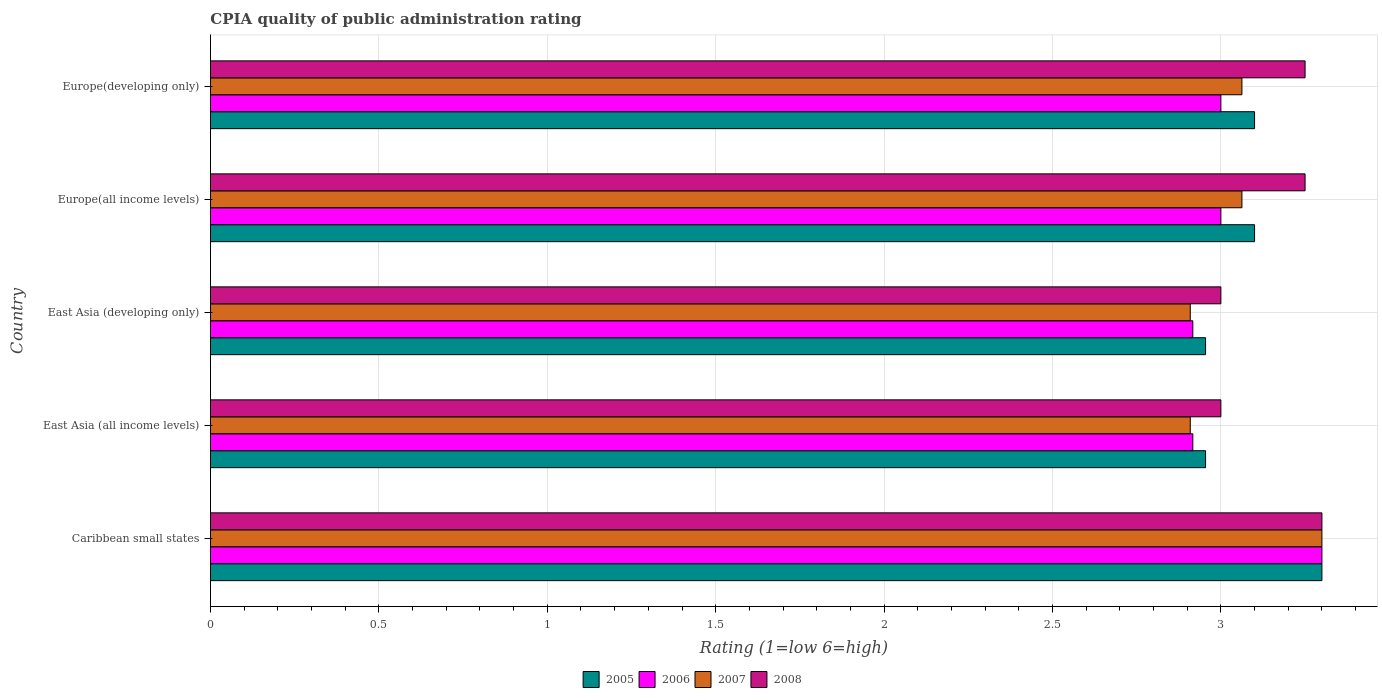How many different coloured bars are there?
Offer a terse response. 4. How many groups of bars are there?
Offer a very short reply. 5. Are the number of bars per tick equal to the number of legend labels?
Give a very brief answer. Yes. Are the number of bars on each tick of the Y-axis equal?
Offer a very short reply. Yes. How many bars are there on the 4th tick from the bottom?
Keep it short and to the point. 4. What is the label of the 3rd group of bars from the top?
Your answer should be very brief. East Asia (developing only). In how many cases, is the number of bars for a given country not equal to the number of legend labels?
Your answer should be compact. 0. What is the CPIA rating in 2006 in East Asia (developing only)?
Give a very brief answer. 2.92. Across all countries, what is the maximum CPIA rating in 2007?
Your answer should be very brief. 3.3. Across all countries, what is the minimum CPIA rating in 2005?
Offer a very short reply. 2.95. In which country was the CPIA rating in 2007 maximum?
Offer a very short reply. Caribbean small states. In which country was the CPIA rating in 2005 minimum?
Offer a very short reply. East Asia (all income levels). What is the total CPIA rating in 2007 in the graph?
Your response must be concise. 15.24. What is the difference between the CPIA rating in 2007 in East Asia (developing only) and that in Europe(all income levels)?
Your answer should be very brief. -0.15. What is the difference between the CPIA rating in 2006 in Caribbean small states and the CPIA rating in 2008 in Europe(all income levels)?
Keep it short and to the point. 0.05. What is the average CPIA rating in 2007 per country?
Offer a terse response. 3.05. What is the difference between the CPIA rating in 2008 and CPIA rating in 2005 in Europe(all income levels)?
Make the answer very short. 0.15. In how many countries, is the CPIA rating in 2008 greater than 0.5 ?
Provide a succinct answer. 5. What is the ratio of the CPIA rating in 2006 in Caribbean small states to that in Europe(all income levels)?
Give a very brief answer. 1.1. Is the CPIA rating in 2005 in Europe(all income levels) less than that in Europe(developing only)?
Give a very brief answer. No. Is the difference between the CPIA rating in 2008 in Caribbean small states and Europe(all income levels) greater than the difference between the CPIA rating in 2005 in Caribbean small states and Europe(all income levels)?
Your answer should be very brief. No. What is the difference between the highest and the second highest CPIA rating in 2006?
Offer a very short reply. 0.3. What is the difference between the highest and the lowest CPIA rating in 2005?
Make the answer very short. 0.35. In how many countries, is the CPIA rating in 2005 greater than the average CPIA rating in 2005 taken over all countries?
Ensure brevity in your answer.  3. Is the sum of the CPIA rating in 2007 in East Asia (all income levels) and Europe(all income levels) greater than the maximum CPIA rating in 2008 across all countries?
Make the answer very short. Yes. What does the 4th bar from the bottom in Europe(developing only) represents?
Your answer should be very brief. 2008. How many countries are there in the graph?
Offer a very short reply. 5. What is the difference between two consecutive major ticks on the X-axis?
Your answer should be very brief. 0.5. Does the graph contain any zero values?
Your answer should be compact. No. Where does the legend appear in the graph?
Give a very brief answer. Bottom center. How many legend labels are there?
Your answer should be very brief. 4. What is the title of the graph?
Provide a succinct answer. CPIA quality of public administration rating. What is the label or title of the X-axis?
Make the answer very short. Rating (1=low 6=high). What is the label or title of the Y-axis?
Provide a succinct answer. Country. What is the Rating (1=low 6=high) in 2005 in Caribbean small states?
Provide a short and direct response. 3.3. What is the Rating (1=low 6=high) in 2005 in East Asia (all income levels)?
Provide a short and direct response. 2.95. What is the Rating (1=low 6=high) in 2006 in East Asia (all income levels)?
Provide a succinct answer. 2.92. What is the Rating (1=low 6=high) in 2007 in East Asia (all income levels)?
Offer a very short reply. 2.91. What is the Rating (1=low 6=high) in 2005 in East Asia (developing only)?
Your answer should be compact. 2.95. What is the Rating (1=low 6=high) in 2006 in East Asia (developing only)?
Provide a short and direct response. 2.92. What is the Rating (1=low 6=high) in 2007 in East Asia (developing only)?
Offer a very short reply. 2.91. What is the Rating (1=low 6=high) in 2007 in Europe(all income levels)?
Make the answer very short. 3.06. What is the Rating (1=low 6=high) of 2007 in Europe(developing only)?
Provide a succinct answer. 3.06. Across all countries, what is the maximum Rating (1=low 6=high) in 2005?
Your answer should be compact. 3.3. Across all countries, what is the maximum Rating (1=low 6=high) of 2006?
Offer a terse response. 3.3. Across all countries, what is the minimum Rating (1=low 6=high) of 2005?
Your answer should be very brief. 2.95. Across all countries, what is the minimum Rating (1=low 6=high) of 2006?
Keep it short and to the point. 2.92. Across all countries, what is the minimum Rating (1=low 6=high) in 2007?
Your answer should be compact. 2.91. Across all countries, what is the minimum Rating (1=low 6=high) in 2008?
Ensure brevity in your answer.  3. What is the total Rating (1=low 6=high) of 2005 in the graph?
Offer a terse response. 15.41. What is the total Rating (1=low 6=high) of 2006 in the graph?
Your response must be concise. 15.13. What is the total Rating (1=low 6=high) in 2007 in the graph?
Offer a terse response. 15.24. What is the total Rating (1=low 6=high) in 2008 in the graph?
Your answer should be compact. 15.8. What is the difference between the Rating (1=low 6=high) in 2005 in Caribbean small states and that in East Asia (all income levels)?
Give a very brief answer. 0.35. What is the difference between the Rating (1=low 6=high) in 2006 in Caribbean small states and that in East Asia (all income levels)?
Give a very brief answer. 0.38. What is the difference between the Rating (1=low 6=high) of 2007 in Caribbean small states and that in East Asia (all income levels)?
Make the answer very short. 0.39. What is the difference between the Rating (1=low 6=high) of 2008 in Caribbean small states and that in East Asia (all income levels)?
Make the answer very short. 0.3. What is the difference between the Rating (1=low 6=high) in 2005 in Caribbean small states and that in East Asia (developing only)?
Give a very brief answer. 0.35. What is the difference between the Rating (1=low 6=high) of 2006 in Caribbean small states and that in East Asia (developing only)?
Your answer should be very brief. 0.38. What is the difference between the Rating (1=low 6=high) in 2007 in Caribbean small states and that in East Asia (developing only)?
Offer a very short reply. 0.39. What is the difference between the Rating (1=low 6=high) in 2006 in Caribbean small states and that in Europe(all income levels)?
Your answer should be very brief. 0.3. What is the difference between the Rating (1=low 6=high) of 2007 in Caribbean small states and that in Europe(all income levels)?
Make the answer very short. 0.24. What is the difference between the Rating (1=low 6=high) of 2008 in Caribbean small states and that in Europe(all income levels)?
Your response must be concise. 0.05. What is the difference between the Rating (1=low 6=high) in 2007 in Caribbean small states and that in Europe(developing only)?
Provide a short and direct response. 0.24. What is the difference between the Rating (1=low 6=high) of 2005 in East Asia (all income levels) and that in East Asia (developing only)?
Make the answer very short. 0. What is the difference between the Rating (1=low 6=high) of 2007 in East Asia (all income levels) and that in East Asia (developing only)?
Offer a terse response. 0. What is the difference between the Rating (1=low 6=high) in 2005 in East Asia (all income levels) and that in Europe(all income levels)?
Give a very brief answer. -0.15. What is the difference between the Rating (1=low 6=high) of 2006 in East Asia (all income levels) and that in Europe(all income levels)?
Provide a succinct answer. -0.08. What is the difference between the Rating (1=low 6=high) in 2007 in East Asia (all income levels) and that in Europe(all income levels)?
Ensure brevity in your answer.  -0.15. What is the difference between the Rating (1=low 6=high) of 2008 in East Asia (all income levels) and that in Europe(all income levels)?
Provide a short and direct response. -0.25. What is the difference between the Rating (1=low 6=high) in 2005 in East Asia (all income levels) and that in Europe(developing only)?
Your response must be concise. -0.15. What is the difference between the Rating (1=low 6=high) in 2006 in East Asia (all income levels) and that in Europe(developing only)?
Make the answer very short. -0.08. What is the difference between the Rating (1=low 6=high) in 2007 in East Asia (all income levels) and that in Europe(developing only)?
Keep it short and to the point. -0.15. What is the difference between the Rating (1=low 6=high) of 2005 in East Asia (developing only) and that in Europe(all income levels)?
Offer a terse response. -0.15. What is the difference between the Rating (1=low 6=high) in 2006 in East Asia (developing only) and that in Europe(all income levels)?
Give a very brief answer. -0.08. What is the difference between the Rating (1=low 6=high) of 2007 in East Asia (developing only) and that in Europe(all income levels)?
Offer a very short reply. -0.15. What is the difference between the Rating (1=low 6=high) of 2008 in East Asia (developing only) and that in Europe(all income levels)?
Provide a short and direct response. -0.25. What is the difference between the Rating (1=low 6=high) in 2005 in East Asia (developing only) and that in Europe(developing only)?
Make the answer very short. -0.15. What is the difference between the Rating (1=low 6=high) in 2006 in East Asia (developing only) and that in Europe(developing only)?
Your answer should be very brief. -0.08. What is the difference between the Rating (1=low 6=high) of 2007 in East Asia (developing only) and that in Europe(developing only)?
Provide a succinct answer. -0.15. What is the difference between the Rating (1=low 6=high) of 2007 in Europe(all income levels) and that in Europe(developing only)?
Your response must be concise. 0. What is the difference between the Rating (1=low 6=high) in 2005 in Caribbean small states and the Rating (1=low 6=high) in 2006 in East Asia (all income levels)?
Offer a very short reply. 0.38. What is the difference between the Rating (1=low 6=high) of 2005 in Caribbean small states and the Rating (1=low 6=high) of 2007 in East Asia (all income levels)?
Ensure brevity in your answer.  0.39. What is the difference between the Rating (1=low 6=high) in 2006 in Caribbean small states and the Rating (1=low 6=high) in 2007 in East Asia (all income levels)?
Provide a short and direct response. 0.39. What is the difference between the Rating (1=low 6=high) of 2006 in Caribbean small states and the Rating (1=low 6=high) of 2008 in East Asia (all income levels)?
Provide a short and direct response. 0.3. What is the difference between the Rating (1=low 6=high) of 2007 in Caribbean small states and the Rating (1=low 6=high) of 2008 in East Asia (all income levels)?
Make the answer very short. 0.3. What is the difference between the Rating (1=low 6=high) of 2005 in Caribbean small states and the Rating (1=low 6=high) of 2006 in East Asia (developing only)?
Offer a terse response. 0.38. What is the difference between the Rating (1=low 6=high) in 2005 in Caribbean small states and the Rating (1=low 6=high) in 2007 in East Asia (developing only)?
Ensure brevity in your answer.  0.39. What is the difference between the Rating (1=low 6=high) in 2006 in Caribbean small states and the Rating (1=low 6=high) in 2007 in East Asia (developing only)?
Provide a succinct answer. 0.39. What is the difference between the Rating (1=low 6=high) of 2007 in Caribbean small states and the Rating (1=low 6=high) of 2008 in East Asia (developing only)?
Make the answer very short. 0.3. What is the difference between the Rating (1=low 6=high) in 2005 in Caribbean small states and the Rating (1=low 6=high) in 2006 in Europe(all income levels)?
Offer a very short reply. 0.3. What is the difference between the Rating (1=low 6=high) in 2005 in Caribbean small states and the Rating (1=low 6=high) in 2007 in Europe(all income levels)?
Keep it short and to the point. 0.24. What is the difference between the Rating (1=low 6=high) of 2006 in Caribbean small states and the Rating (1=low 6=high) of 2007 in Europe(all income levels)?
Your response must be concise. 0.24. What is the difference between the Rating (1=low 6=high) in 2006 in Caribbean small states and the Rating (1=low 6=high) in 2008 in Europe(all income levels)?
Your answer should be compact. 0.05. What is the difference between the Rating (1=low 6=high) in 2005 in Caribbean small states and the Rating (1=low 6=high) in 2006 in Europe(developing only)?
Provide a short and direct response. 0.3. What is the difference between the Rating (1=low 6=high) in 2005 in Caribbean small states and the Rating (1=low 6=high) in 2007 in Europe(developing only)?
Ensure brevity in your answer.  0.24. What is the difference between the Rating (1=low 6=high) of 2006 in Caribbean small states and the Rating (1=low 6=high) of 2007 in Europe(developing only)?
Offer a very short reply. 0.24. What is the difference between the Rating (1=low 6=high) in 2006 in Caribbean small states and the Rating (1=low 6=high) in 2008 in Europe(developing only)?
Make the answer very short. 0.05. What is the difference between the Rating (1=low 6=high) in 2005 in East Asia (all income levels) and the Rating (1=low 6=high) in 2006 in East Asia (developing only)?
Offer a very short reply. 0.04. What is the difference between the Rating (1=low 6=high) in 2005 in East Asia (all income levels) and the Rating (1=low 6=high) in 2007 in East Asia (developing only)?
Your answer should be very brief. 0.05. What is the difference between the Rating (1=low 6=high) in 2005 in East Asia (all income levels) and the Rating (1=low 6=high) in 2008 in East Asia (developing only)?
Provide a succinct answer. -0.05. What is the difference between the Rating (1=low 6=high) in 2006 in East Asia (all income levels) and the Rating (1=low 6=high) in 2007 in East Asia (developing only)?
Make the answer very short. 0.01. What is the difference between the Rating (1=low 6=high) in 2006 in East Asia (all income levels) and the Rating (1=low 6=high) in 2008 in East Asia (developing only)?
Give a very brief answer. -0.08. What is the difference between the Rating (1=low 6=high) in 2007 in East Asia (all income levels) and the Rating (1=low 6=high) in 2008 in East Asia (developing only)?
Your answer should be compact. -0.09. What is the difference between the Rating (1=low 6=high) in 2005 in East Asia (all income levels) and the Rating (1=low 6=high) in 2006 in Europe(all income levels)?
Provide a succinct answer. -0.05. What is the difference between the Rating (1=low 6=high) of 2005 in East Asia (all income levels) and the Rating (1=low 6=high) of 2007 in Europe(all income levels)?
Keep it short and to the point. -0.11. What is the difference between the Rating (1=low 6=high) of 2005 in East Asia (all income levels) and the Rating (1=low 6=high) of 2008 in Europe(all income levels)?
Give a very brief answer. -0.3. What is the difference between the Rating (1=low 6=high) of 2006 in East Asia (all income levels) and the Rating (1=low 6=high) of 2007 in Europe(all income levels)?
Offer a very short reply. -0.15. What is the difference between the Rating (1=low 6=high) of 2007 in East Asia (all income levels) and the Rating (1=low 6=high) of 2008 in Europe(all income levels)?
Your response must be concise. -0.34. What is the difference between the Rating (1=low 6=high) in 2005 in East Asia (all income levels) and the Rating (1=low 6=high) in 2006 in Europe(developing only)?
Ensure brevity in your answer.  -0.05. What is the difference between the Rating (1=low 6=high) in 2005 in East Asia (all income levels) and the Rating (1=low 6=high) in 2007 in Europe(developing only)?
Your answer should be very brief. -0.11. What is the difference between the Rating (1=low 6=high) of 2005 in East Asia (all income levels) and the Rating (1=low 6=high) of 2008 in Europe(developing only)?
Give a very brief answer. -0.3. What is the difference between the Rating (1=low 6=high) of 2006 in East Asia (all income levels) and the Rating (1=low 6=high) of 2007 in Europe(developing only)?
Give a very brief answer. -0.15. What is the difference between the Rating (1=low 6=high) of 2006 in East Asia (all income levels) and the Rating (1=low 6=high) of 2008 in Europe(developing only)?
Give a very brief answer. -0.33. What is the difference between the Rating (1=low 6=high) of 2007 in East Asia (all income levels) and the Rating (1=low 6=high) of 2008 in Europe(developing only)?
Your response must be concise. -0.34. What is the difference between the Rating (1=low 6=high) in 2005 in East Asia (developing only) and the Rating (1=low 6=high) in 2006 in Europe(all income levels)?
Your answer should be very brief. -0.05. What is the difference between the Rating (1=low 6=high) in 2005 in East Asia (developing only) and the Rating (1=low 6=high) in 2007 in Europe(all income levels)?
Provide a succinct answer. -0.11. What is the difference between the Rating (1=low 6=high) of 2005 in East Asia (developing only) and the Rating (1=low 6=high) of 2008 in Europe(all income levels)?
Your response must be concise. -0.3. What is the difference between the Rating (1=low 6=high) of 2006 in East Asia (developing only) and the Rating (1=low 6=high) of 2007 in Europe(all income levels)?
Offer a very short reply. -0.15. What is the difference between the Rating (1=low 6=high) of 2006 in East Asia (developing only) and the Rating (1=low 6=high) of 2008 in Europe(all income levels)?
Your response must be concise. -0.33. What is the difference between the Rating (1=low 6=high) in 2007 in East Asia (developing only) and the Rating (1=low 6=high) in 2008 in Europe(all income levels)?
Provide a short and direct response. -0.34. What is the difference between the Rating (1=low 6=high) of 2005 in East Asia (developing only) and the Rating (1=low 6=high) of 2006 in Europe(developing only)?
Keep it short and to the point. -0.05. What is the difference between the Rating (1=low 6=high) of 2005 in East Asia (developing only) and the Rating (1=low 6=high) of 2007 in Europe(developing only)?
Your answer should be compact. -0.11. What is the difference between the Rating (1=low 6=high) of 2005 in East Asia (developing only) and the Rating (1=low 6=high) of 2008 in Europe(developing only)?
Give a very brief answer. -0.3. What is the difference between the Rating (1=low 6=high) in 2006 in East Asia (developing only) and the Rating (1=low 6=high) in 2007 in Europe(developing only)?
Give a very brief answer. -0.15. What is the difference between the Rating (1=low 6=high) of 2007 in East Asia (developing only) and the Rating (1=low 6=high) of 2008 in Europe(developing only)?
Provide a short and direct response. -0.34. What is the difference between the Rating (1=low 6=high) in 2005 in Europe(all income levels) and the Rating (1=low 6=high) in 2007 in Europe(developing only)?
Provide a succinct answer. 0.04. What is the difference between the Rating (1=low 6=high) in 2005 in Europe(all income levels) and the Rating (1=low 6=high) in 2008 in Europe(developing only)?
Give a very brief answer. -0.15. What is the difference between the Rating (1=low 6=high) of 2006 in Europe(all income levels) and the Rating (1=low 6=high) of 2007 in Europe(developing only)?
Your response must be concise. -0.06. What is the difference between the Rating (1=low 6=high) in 2006 in Europe(all income levels) and the Rating (1=low 6=high) in 2008 in Europe(developing only)?
Your answer should be compact. -0.25. What is the difference between the Rating (1=low 6=high) in 2007 in Europe(all income levels) and the Rating (1=low 6=high) in 2008 in Europe(developing only)?
Make the answer very short. -0.19. What is the average Rating (1=low 6=high) of 2005 per country?
Make the answer very short. 3.08. What is the average Rating (1=low 6=high) of 2006 per country?
Offer a very short reply. 3.03. What is the average Rating (1=low 6=high) of 2007 per country?
Your response must be concise. 3.05. What is the average Rating (1=low 6=high) in 2008 per country?
Provide a succinct answer. 3.16. What is the difference between the Rating (1=low 6=high) of 2005 and Rating (1=low 6=high) of 2006 in Caribbean small states?
Your response must be concise. 0. What is the difference between the Rating (1=low 6=high) of 2005 and Rating (1=low 6=high) of 2006 in East Asia (all income levels)?
Ensure brevity in your answer.  0.04. What is the difference between the Rating (1=low 6=high) of 2005 and Rating (1=low 6=high) of 2007 in East Asia (all income levels)?
Your answer should be compact. 0.05. What is the difference between the Rating (1=low 6=high) in 2005 and Rating (1=low 6=high) in 2008 in East Asia (all income levels)?
Offer a terse response. -0.05. What is the difference between the Rating (1=low 6=high) in 2006 and Rating (1=low 6=high) in 2007 in East Asia (all income levels)?
Offer a very short reply. 0.01. What is the difference between the Rating (1=low 6=high) of 2006 and Rating (1=low 6=high) of 2008 in East Asia (all income levels)?
Ensure brevity in your answer.  -0.08. What is the difference between the Rating (1=low 6=high) in 2007 and Rating (1=low 6=high) in 2008 in East Asia (all income levels)?
Your response must be concise. -0.09. What is the difference between the Rating (1=low 6=high) of 2005 and Rating (1=low 6=high) of 2006 in East Asia (developing only)?
Your answer should be very brief. 0.04. What is the difference between the Rating (1=low 6=high) in 2005 and Rating (1=low 6=high) in 2007 in East Asia (developing only)?
Keep it short and to the point. 0.05. What is the difference between the Rating (1=low 6=high) of 2005 and Rating (1=low 6=high) of 2008 in East Asia (developing only)?
Give a very brief answer. -0.05. What is the difference between the Rating (1=low 6=high) of 2006 and Rating (1=low 6=high) of 2007 in East Asia (developing only)?
Provide a succinct answer. 0.01. What is the difference between the Rating (1=low 6=high) in 2006 and Rating (1=low 6=high) in 2008 in East Asia (developing only)?
Your answer should be compact. -0.08. What is the difference between the Rating (1=low 6=high) in 2007 and Rating (1=low 6=high) in 2008 in East Asia (developing only)?
Provide a short and direct response. -0.09. What is the difference between the Rating (1=low 6=high) in 2005 and Rating (1=low 6=high) in 2007 in Europe(all income levels)?
Your answer should be compact. 0.04. What is the difference between the Rating (1=low 6=high) in 2005 and Rating (1=low 6=high) in 2008 in Europe(all income levels)?
Make the answer very short. -0.15. What is the difference between the Rating (1=low 6=high) in 2006 and Rating (1=low 6=high) in 2007 in Europe(all income levels)?
Your answer should be compact. -0.06. What is the difference between the Rating (1=low 6=high) in 2007 and Rating (1=low 6=high) in 2008 in Europe(all income levels)?
Keep it short and to the point. -0.19. What is the difference between the Rating (1=low 6=high) of 2005 and Rating (1=low 6=high) of 2006 in Europe(developing only)?
Provide a succinct answer. 0.1. What is the difference between the Rating (1=low 6=high) in 2005 and Rating (1=low 6=high) in 2007 in Europe(developing only)?
Provide a short and direct response. 0.04. What is the difference between the Rating (1=low 6=high) in 2006 and Rating (1=low 6=high) in 2007 in Europe(developing only)?
Make the answer very short. -0.06. What is the difference between the Rating (1=low 6=high) of 2007 and Rating (1=low 6=high) of 2008 in Europe(developing only)?
Give a very brief answer. -0.19. What is the ratio of the Rating (1=low 6=high) of 2005 in Caribbean small states to that in East Asia (all income levels)?
Your response must be concise. 1.12. What is the ratio of the Rating (1=low 6=high) in 2006 in Caribbean small states to that in East Asia (all income levels)?
Your answer should be very brief. 1.13. What is the ratio of the Rating (1=low 6=high) of 2007 in Caribbean small states to that in East Asia (all income levels)?
Your answer should be compact. 1.13. What is the ratio of the Rating (1=low 6=high) in 2005 in Caribbean small states to that in East Asia (developing only)?
Make the answer very short. 1.12. What is the ratio of the Rating (1=low 6=high) in 2006 in Caribbean small states to that in East Asia (developing only)?
Offer a very short reply. 1.13. What is the ratio of the Rating (1=low 6=high) of 2007 in Caribbean small states to that in East Asia (developing only)?
Make the answer very short. 1.13. What is the ratio of the Rating (1=low 6=high) in 2005 in Caribbean small states to that in Europe(all income levels)?
Provide a short and direct response. 1.06. What is the ratio of the Rating (1=low 6=high) of 2006 in Caribbean small states to that in Europe(all income levels)?
Make the answer very short. 1.1. What is the ratio of the Rating (1=low 6=high) in 2007 in Caribbean small states to that in Europe(all income levels)?
Provide a short and direct response. 1.08. What is the ratio of the Rating (1=low 6=high) in 2008 in Caribbean small states to that in Europe(all income levels)?
Ensure brevity in your answer.  1.02. What is the ratio of the Rating (1=low 6=high) of 2005 in Caribbean small states to that in Europe(developing only)?
Keep it short and to the point. 1.06. What is the ratio of the Rating (1=low 6=high) in 2007 in Caribbean small states to that in Europe(developing only)?
Keep it short and to the point. 1.08. What is the ratio of the Rating (1=low 6=high) in 2008 in Caribbean small states to that in Europe(developing only)?
Provide a short and direct response. 1.02. What is the ratio of the Rating (1=low 6=high) in 2006 in East Asia (all income levels) to that in East Asia (developing only)?
Provide a short and direct response. 1. What is the ratio of the Rating (1=low 6=high) in 2007 in East Asia (all income levels) to that in East Asia (developing only)?
Provide a succinct answer. 1. What is the ratio of the Rating (1=low 6=high) in 2005 in East Asia (all income levels) to that in Europe(all income levels)?
Provide a short and direct response. 0.95. What is the ratio of the Rating (1=low 6=high) of 2006 in East Asia (all income levels) to that in Europe(all income levels)?
Your response must be concise. 0.97. What is the ratio of the Rating (1=low 6=high) of 2007 in East Asia (all income levels) to that in Europe(all income levels)?
Offer a very short reply. 0.95. What is the ratio of the Rating (1=low 6=high) of 2005 in East Asia (all income levels) to that in Europe(developing only)?
Keep it short and to the point. 0.95. What is the ratio of the Rating (1=low 6=high) in 2006 in East Asia (all income levels) to that in Europe(developing only)?
Provide a short and direct response. 0.97. What is the ratio of the Rating (1=low 6=high) in 2007 in East Asia (all income levels) to that in Europe(developing only)?
Provide a succinct answer. 0.95. What is the ratio of the Rating (1=low 6=high) in 2008 in East Asia (all income levels) to that in Europe(developing only)?
Your response must be concise. 0.92. What is the ratio of the Rating (1=low 6=high) in 2005 in East Asia (developing only) to that in Europe(all income levels)?
Keep it short and to the point. 0.95. What is the ratio of the Rating (1=low 6=high) in 2006 in East Asia (developing only) to that in Europe(all income levels)?
Offer a very short reply. 0.97. What is the ratio of the Rating (1=low 6=high) in 2007 in East Asia (developing only) to that in Europe(all income levels)?
Offer a terse response. 0.95. What is the ratio of the Rating (1=low 6=high) of 2005 in East Asia (developing only) to that in Europe(developing only)?
Provide a succinct answer. 0.95. What is the ratio of the Rating (1=low 6=high) in 2006 in East Asia (developing only) to that in Europe(developing only)?
Make the answer very short. 0.97. What is the ratio of the Rating (1=low 6=high) in 2007 in East Asia (developing only) to that in Europe(developing only)?
Give a very brief answer. 0.95. What is the ratio of the Rating (1=low 6=high) of 2006 in Europe(all income levels) to that in Europe(developing only)?
Your response must be concise. 1. What is the ratio of the Rating (1=low 6=high) in 2008 in Europe(all income levels) to that in Europe(developing only)?
Your response must be concise. 1. What is the difference between the highest and the second highest Rating (1=low 6=high) in 2005?
Provide a succinct answer. 0.2. What is the difference between the highest and the second highest Rating (1=low 6=high) of 2006?
Provide a succinct answer. 0.3. What is the difference between the highest and the second highest Rating (1=low 6=high) of 2007?
Make the answer very short. 0.24. What is the difference between the highest and the second highest Rating (1=low 6=high) of 2008?
Your answer should be compact. 0.05. What is the difference between the highest and the lowest Rating (1=low 6=high) in 2005?
Make the answer very short. 0.35. What is the difference between the highest and the lowest Rating (1=low 6=high) in 2006?
Offer a terse response. 0.38. What is the difference between the highest and the lowest Rating (1=low 6=high) of 2007?
Your response must be concise. 0.39. What is the difference between the highest and the lowest Rating (1=low 6=high) of 2008?
Give a very brief answer. 0.3. 